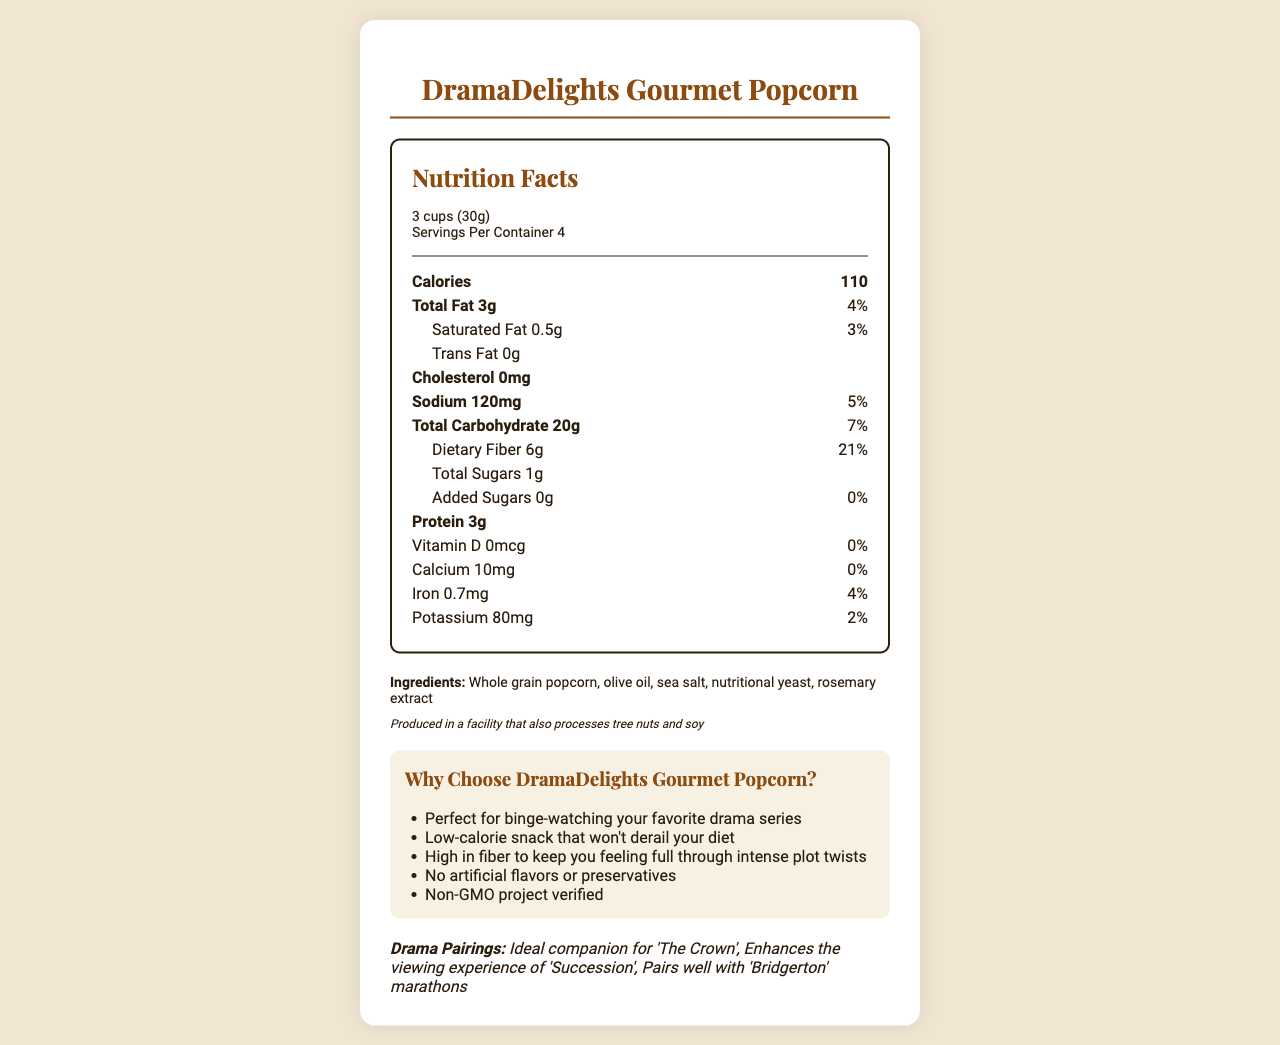what is the serving size? The serving size is clearly mentioned in the section where the nutritional facts for a single serving are outlined.
Answer: 3 cups (30g) how many calories are there per serving? The document lists 110 calories per serving under the “Nutrition Facts” section.
Answer: 110 calories what are the total sugars in a serving? The total sugar content is listed as 1g in the nutritional facts.
Answer: 1g is there any trans fat in the popcorn? The document states that the trans fat amount is 0g.
Answer: No what is the daily value percentage of dietary fiber? Under the dietary fiber section in the nutritional facts, it is indicated that the daily value percentage is 21%.
Answer: 21% how many servings are there in one container? The "Servings Per Container" section of the document mentions there are 4 servings per container.
Answer: 4 does the product contain any artificial flavors or preservatives? One of the marketing claims specifically mentions "No artificial flavors or preservatives."
Answer: No which drama series pair well with this gourmet popcorn? The "Drama Pairings" section of the document lists these three series as ideal companions for DramaDelights Gourmet Popcorn.
Answer: "The Crown", "Succession", "Bridgerton" how much sodium is in a single serving? A. 50mg B. 120mg C. 200mg D. 150mg The sodium content is clearly listed as 120mg per serving in the nutritional facts.
Answer: B. 120mg what is the amount of protein per serving? A. 2g B. 3g C. 4g D. 5g The document indicates there are 3g of protein per serving.
Answer: B. 3g does the product contain cholesterol? The nutritional facts list the cholesterol content as 0mg, indicating there is no cholesterol in the product.
Answer: No what are the main marketing claims of DramaDelights Gourmet Popcorn? The marketing claims section highlights these as key attributes of the product.
Answer: Low-calorie snack, high in fiber, no artificial flavors, Non-GMO what are the main ingredients of the popcorn? The ingredients list specifies these items as the main components of the product.
Answer: Whole grain popcorn, olive oil, sea salt, nutritional yeast, rosemary extract is the product suitable for someone with tree nut allergies? The document mentions that it is produced in a facility that processes tree nuts, but it does not confirm whether the product itself contains tree nuts or not.
Answer: Not enough information summarize the main idea of the document. The document provides a comprehensive overview of the nutritional information, ingredients, packaging details, marketing claims, and recommended drama pairings for DramaDelights Gourmet Popcorn.
Answer: DramaDelights Gourmet Popcorn is a low-calorie, high-fiber snack designed for binge-watching drama series. It contains no artificial flavors or preservatives, is Non-GMO, and is produced in a facility that processes tree nuts and soy. Its savory flavor profile pairs well with shows like "The Crown", "Succession", and "Bridgerton". The product is packaged in a resealable bag for freshness. 